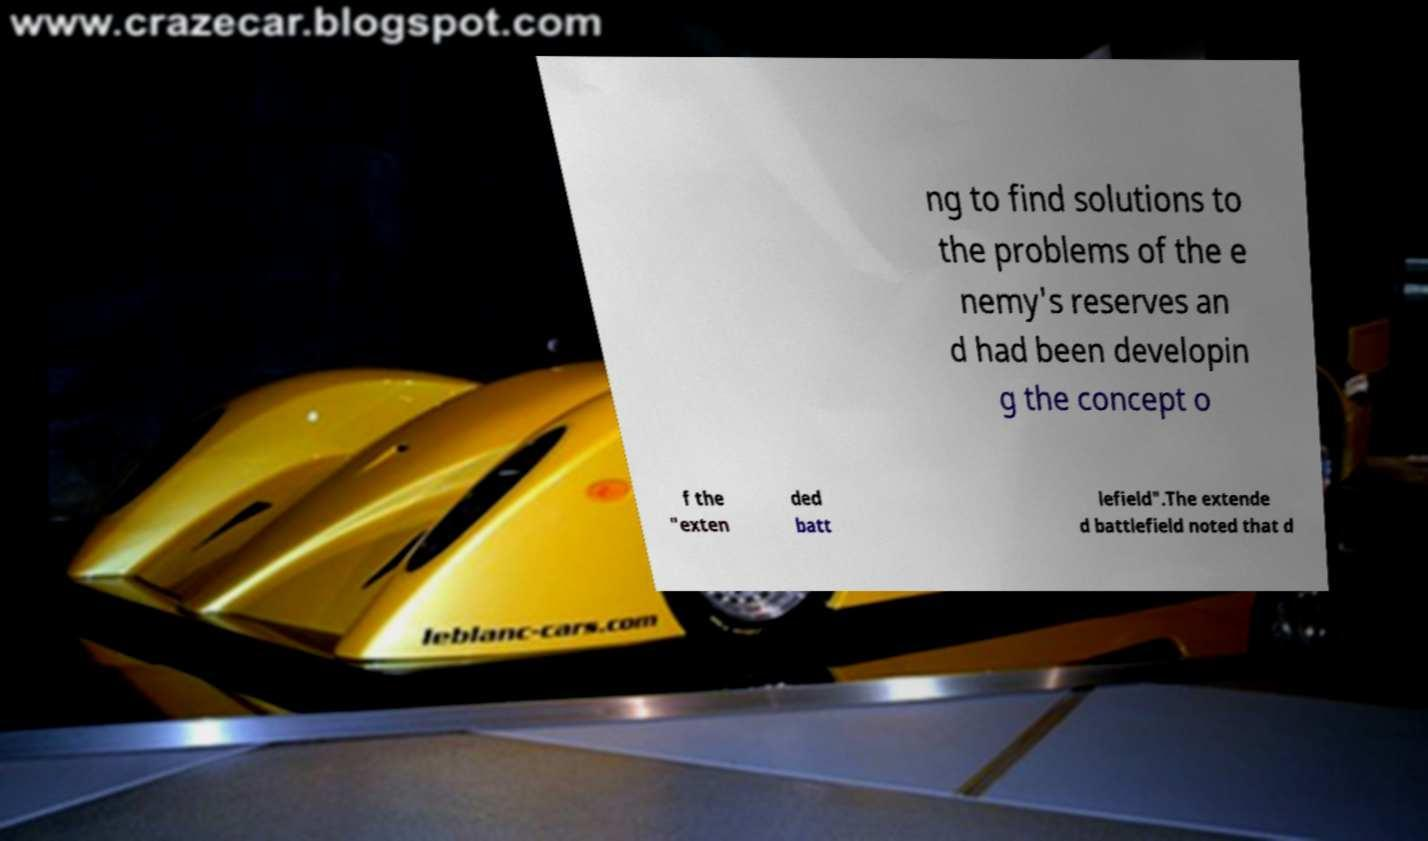Could you extract and type out the text from this image? ng to find solutions to the problems of the e nemy's reserves an d had been developin g the concept o f the "exten ded batt lefield".The extende d battlefield noted that d 